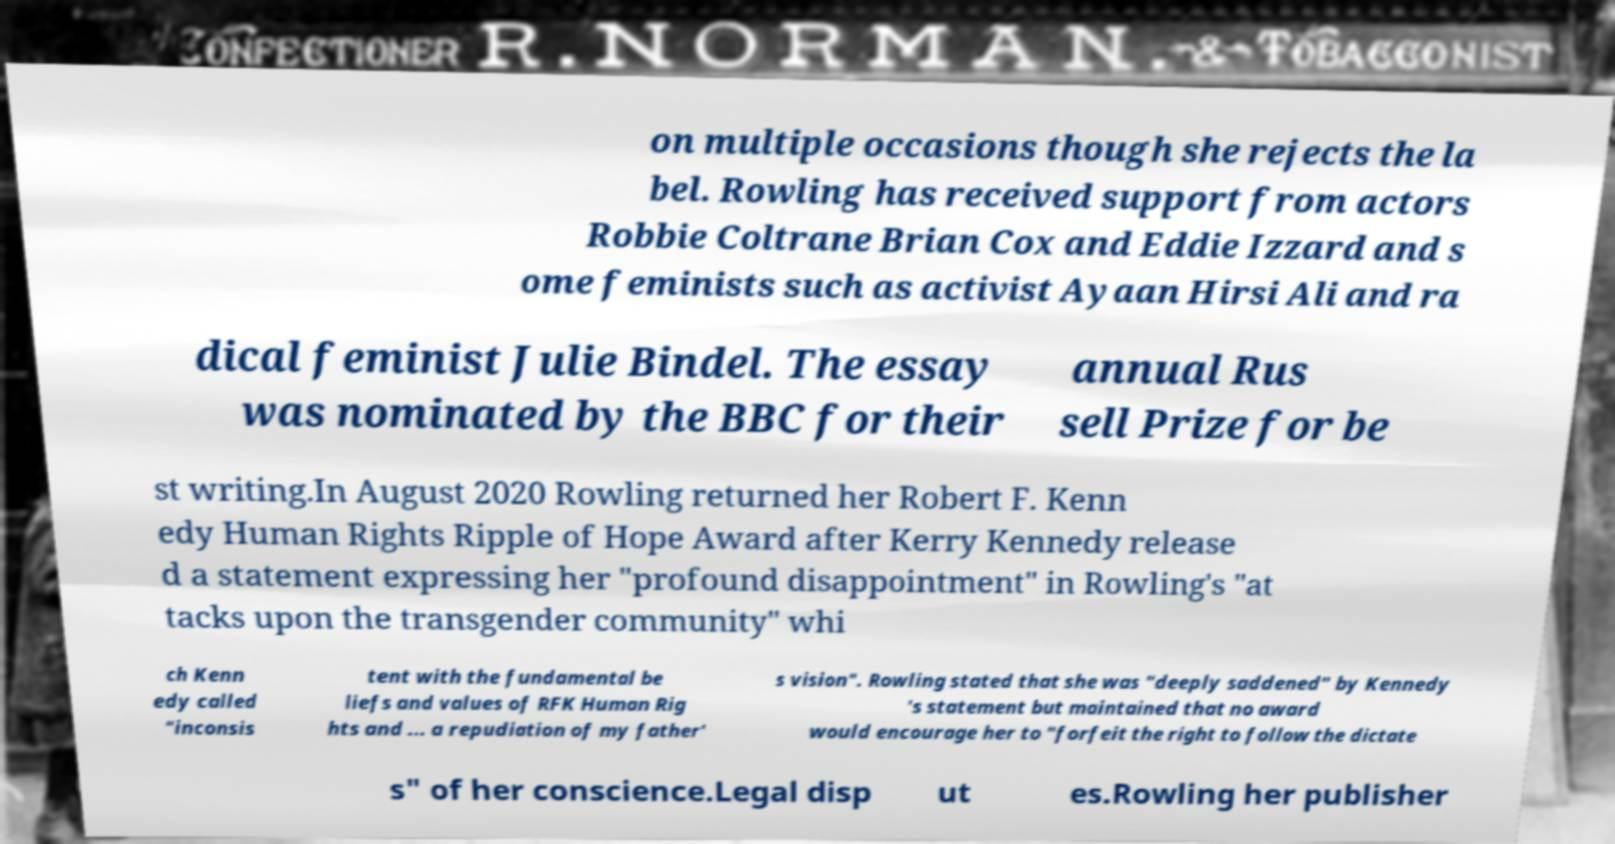Can you read and provide the text displayed in the image?This photo seems to have some interesting text. Can you extract and type it out for me? on multiple occasions though she rejects the la bel. Rowling has received support from actors Robbie Coltrane Brian Cox and Eddie Izzard and s ome feminists such as activist Ayaan Hirsi Ali and ra dical feminist Julie Bindel. The essay was nominated by the BBC for their annual Rus sell Prize for be st writing.In August 2020 Rowling returned her Robert F. Kenn edy Human Rights Ripple of Hope Award after Kerry Kennedy release d a statement expressing her "profound disappointment" in Rowling's "at tacks upon the transgender community" whi ch Kenn edy called "inconsis tent with the fundamental be liefs and values of RFK Human Rig hts and ... a repudiation of my father' s vision". Rowling stated that she was "deeply saddened" by Kennedy 's statement but maintained that no award would encourage her to "forfeit the right to follow the dictate s" of her conscience.Legal disp ut es.Rowling her publisher 